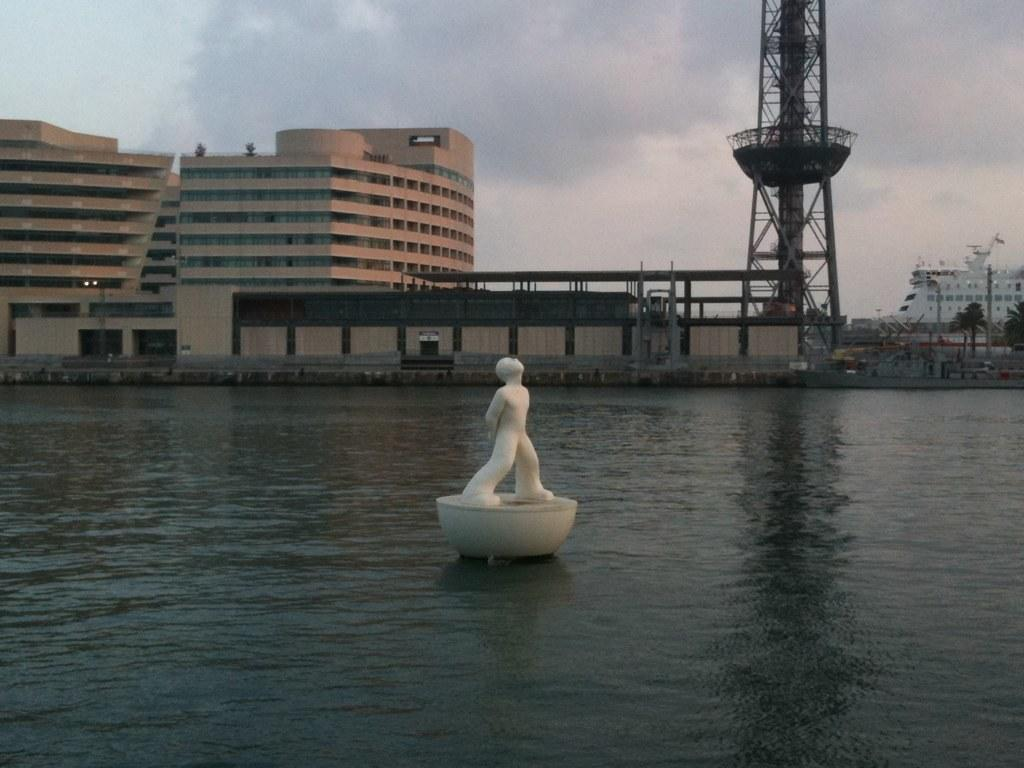What is located in the water in the image? There is a statue in the water in the image. What can be seen in the background of the image? There are buildings, a tower, trees, and a ship in the background. What is the condition of the sky in the image? The sky is cloudy in the background. What type of umbrella is being used by the statue in the image? There is no umbrella present in the image; the statue is in the water without any umbrella. 